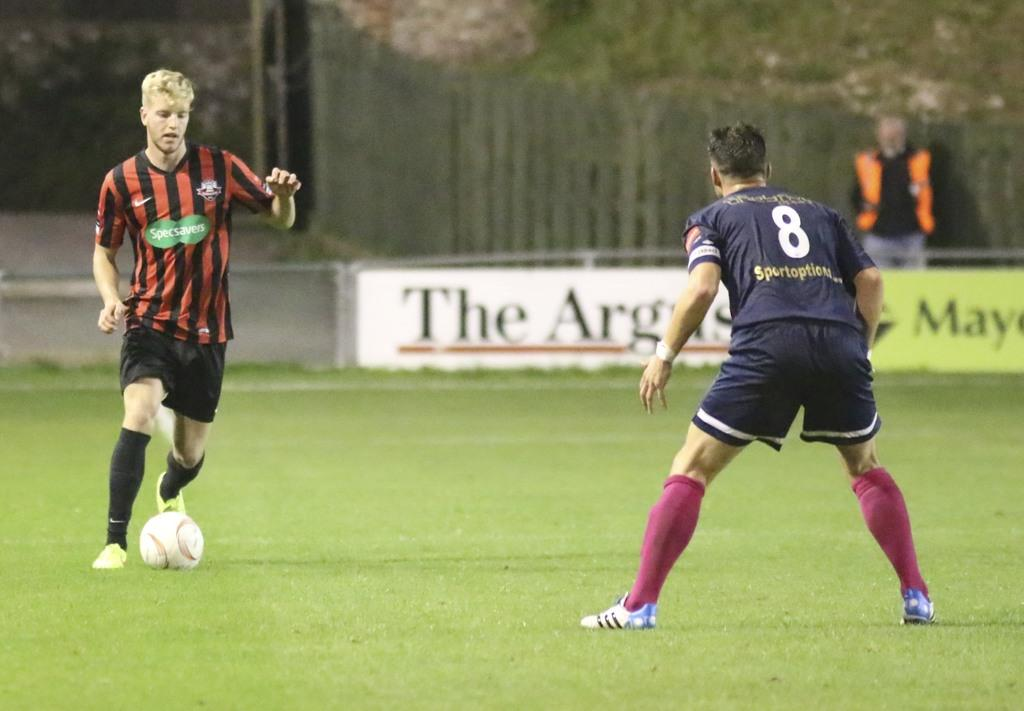<image>
Share a concise interpretation of the image provided. Soccer player wearing jersey number 8 playing defense on another player. 